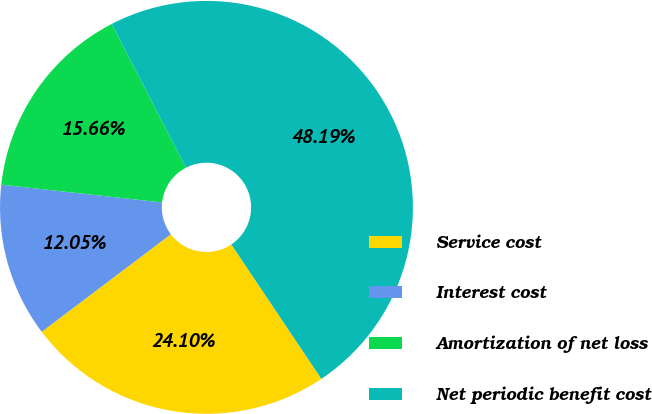Convert chart. <chart><loc_0><loc_0><loc_500><loc_500><pie_chart><fcel>Service cost<fcel>Interest cost<fcel>Amortization of net loss<fcel>Net periodic benefit cost<nl><fcel>24.1%<fcel>12.05%<fcel>15.66%<fcel>48.19%<nl></chart> 